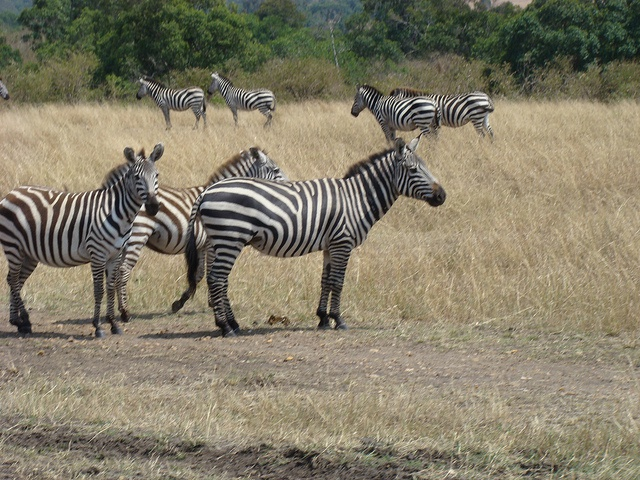Describe the objects in this image and their specific colors. I can see zebra in gray, black, darkgray, and lightgray tones, zebra in gray, black, and darkgray tones, zebra in gray, darkgray, black, and maroon tones, zebra in gray, black, and darkgray tones, and zebra in gray, darkgray, and black tones in this image. 